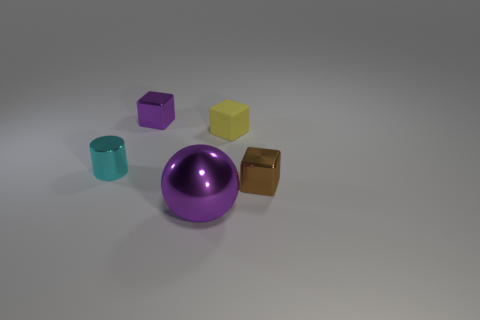Apart from color, how do the textures of these objects differ? The objects do not only vary in color but also in texture. The purple sphere has a smooth and highly reflective surface, indicating a possible lacquered or metallic material. In contrast, the yellow cube seems slightly matte, which may suggest a less polished surface, potentially a painted wood or matte plastic. 